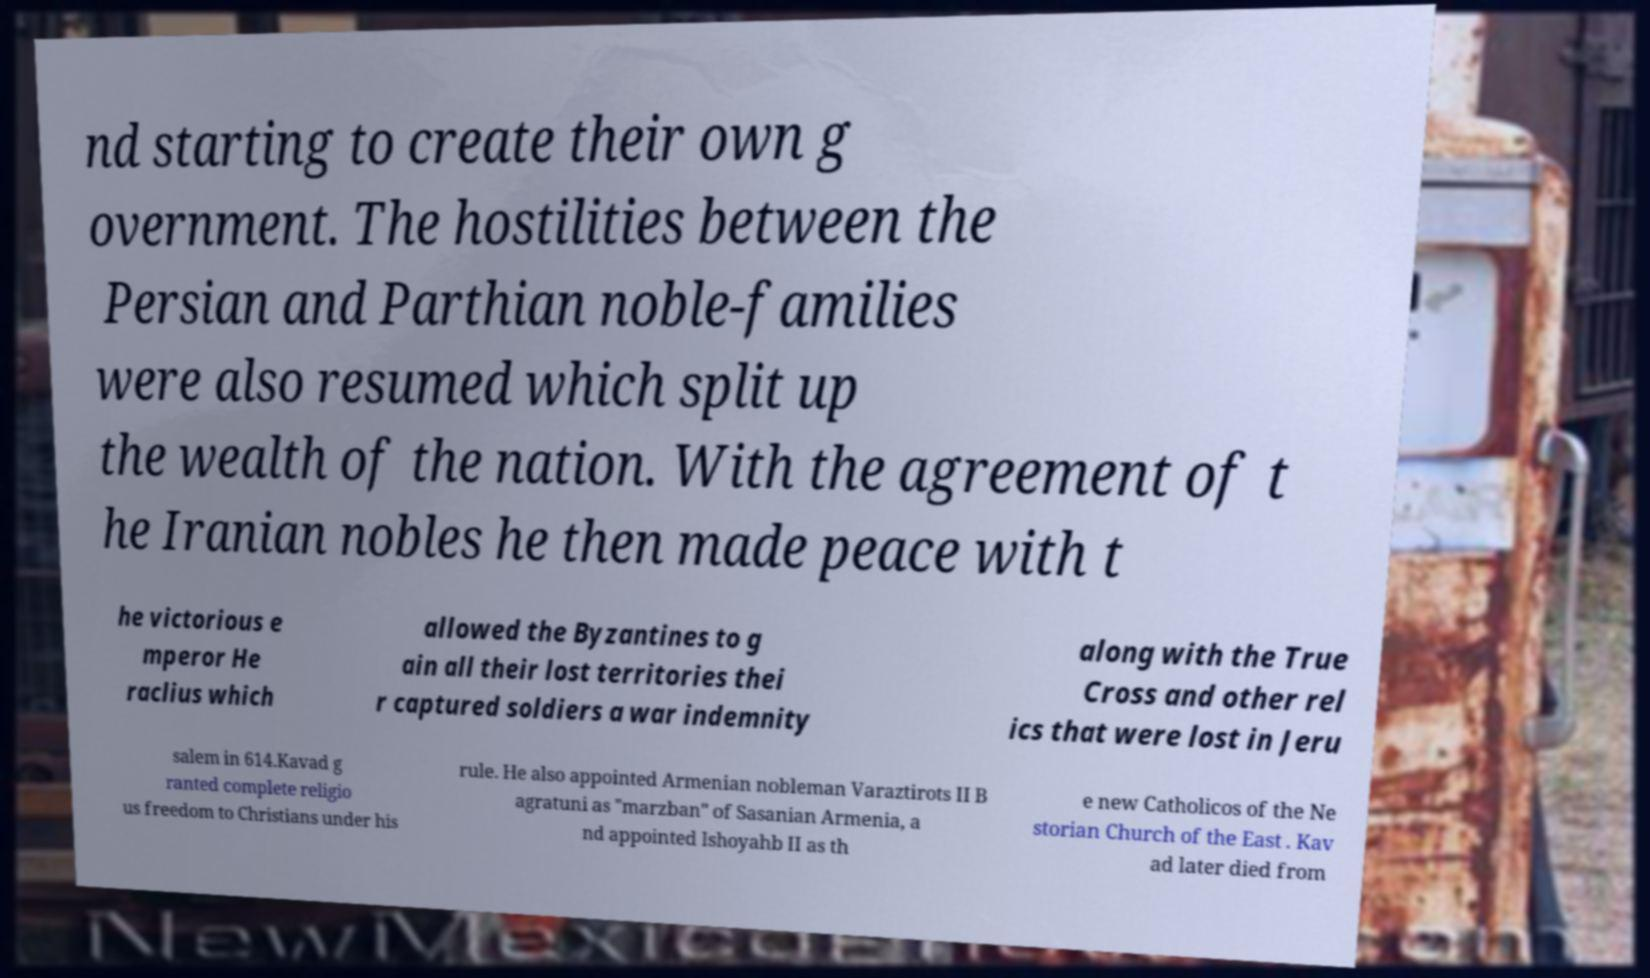Could you extract and type out the text from this image? nd starting to create their own g overnment. The hostilities between the Persian and Parthian noble-families were also resumed which split up the wealth of the nation. With the agreement of t he Iranian nobles he then made peace with t he victorious e mperor He raclius which allowed the Byzantines to g ain all their lost territories thei r captured soldiers a war indemnity along with the True Cross and other rel ics that were lost in Jeru salem in 614.Kavad g ranted complete religio us freedom to Christians under his rule. He also appointed Armenian nobleman Varaztirots II B agratuni as "marzban" of Sasanian Armenia, a nd appointed Ishoyahb II as th e new Catholicos of the Ne storian Church of the East . Kav ad later died from 